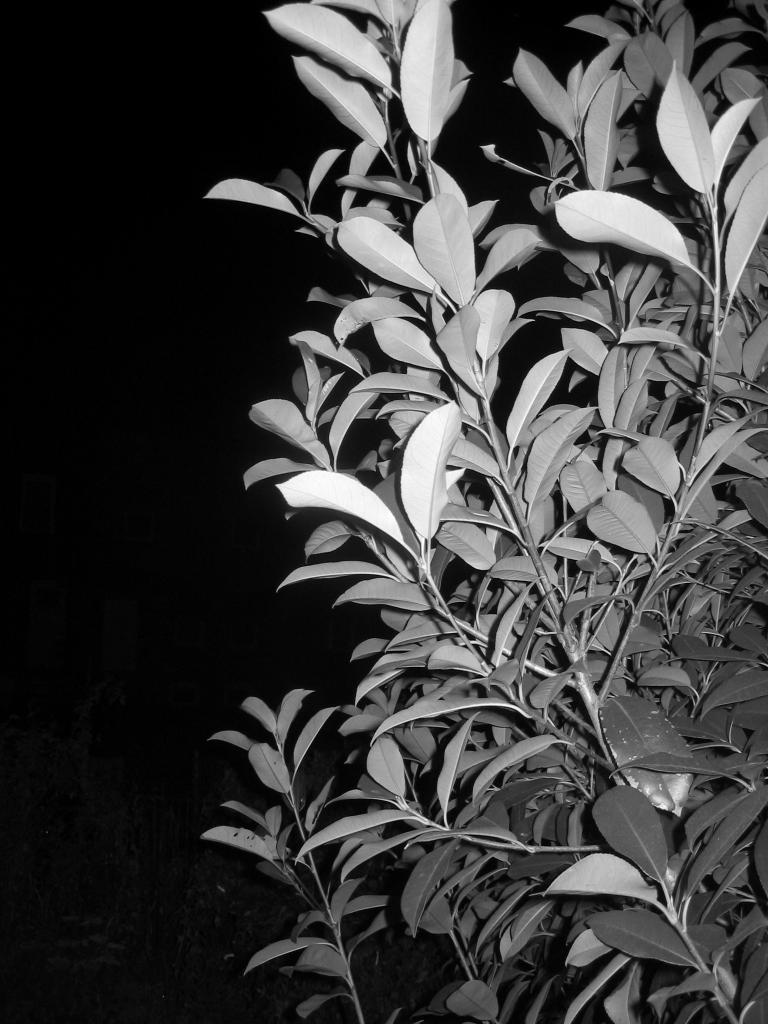What type of living organisms can be seen in the image? Plants can be seen in the image. What feature of the plants is visible in the image? The plants have leaves. How would you describe the background of the image? The background of the image has a dark view. Can you tell me how many ladybugs are sitting on the leaves of the plants in the image? There are no ladybugs present in the image; it only features plants with leaves. What advice would you give to the aunt in the image? There is no aunt present in the image, so it's not possible to give advice to her. 